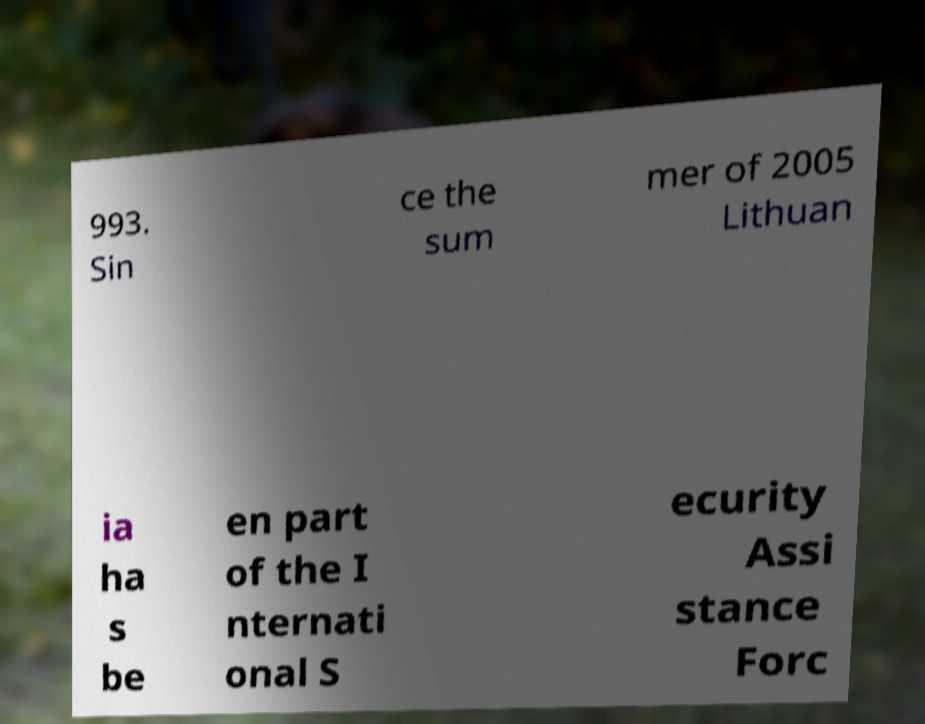Please read and relay the text visible in this image. What does it say? 993. Sin ce the sum mer of 2005 Lithuan ia ha s be en part of the I nternati onal S ecurity Assi stance Forc 